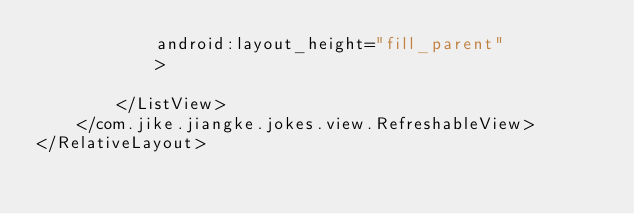Convert code to text. <code><loc_0><loc_0><loc_500><loc_500><_XML_>            android:layout_height="fill_parent"
            >

        </ListView>
    </com.jike.jiangke.jokes.view.RefreshableView>
</RelativeLayout>
</code> 